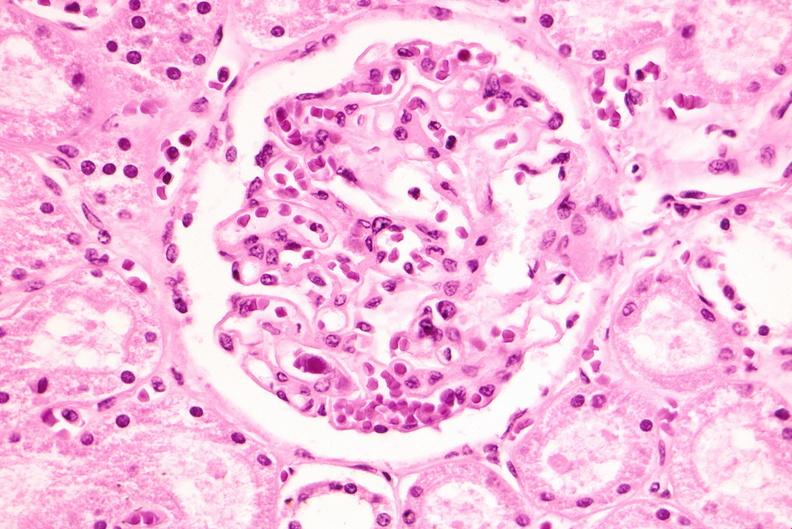where is this?
Answer the question using a single word or phrase. Urinary 